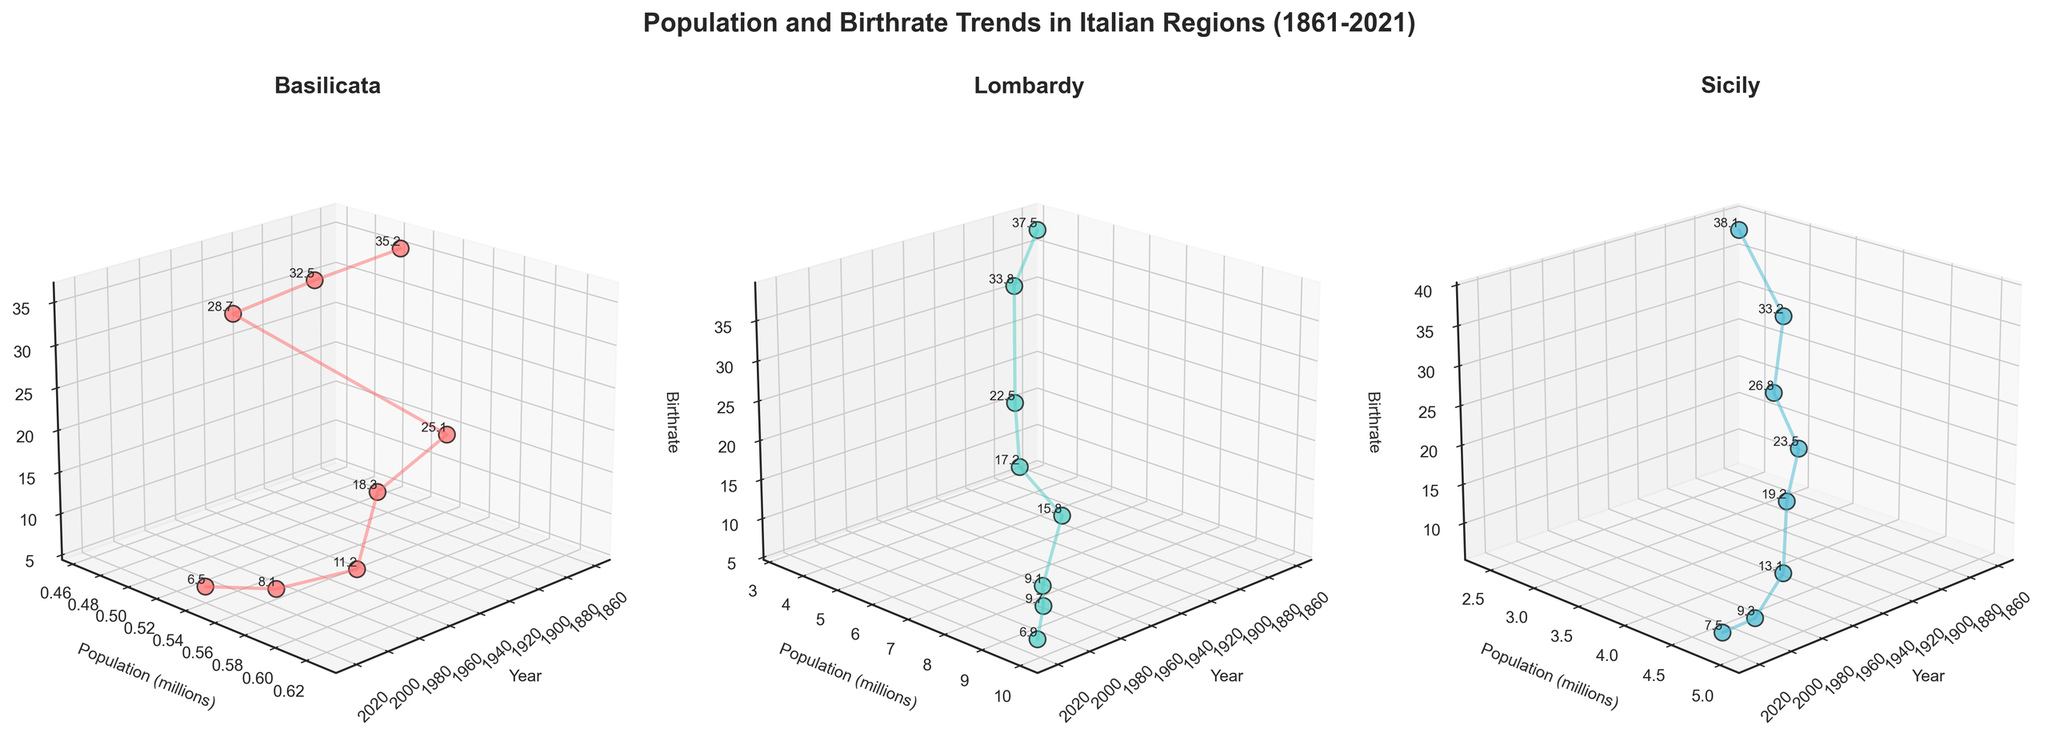Which region has the highest population in 2021? By looking at the scatter plots, we can find the data point for the year 2021. For Basilicata, the population is about 0.54 million, for Lombardy, it is about 9.97 million, and for Sicily, it is around 4.83 million. Lombardy has the highest population.
Answer: Lombardy How did the population of Basilicata change from 1861 to 1951? In the 3D scatter plot for Basilicata, locate the points for 1861 and 1951 on the x-axis for the year. The population in 1861 is about 0.509 million, and in 1951, it is around 0.627 million, indicating an increase of approximately 0.118 million.
Answer: Increased by 0.118 million What was the trend in birthrate for Basilicata from 1951 to 2021? Look at the trail created by the birthrate points for Basilicata from 1951 to 2021. The birthrate decreases from 25.1 to 6.5 over this period.
Answer: Decreasing trend In which year did Lombardy have roughly the same birthrate as Basilicata in 1931? Locate the birthrate for Basilicata in 1931, which is around 28.7. Then check the plot for Lombardy and see which year has a similar birthrate. Lombardy in 1861 has a birthrate around 30, which is close.
Answer: 1861 Compare the birthrate trends for Sicily and Basilicata between 1861 and 2021. Observe the birthrate lines in the 3D plots for both regions. Both regions show a significant decrease in birthrate from 1861 to 2021.
Answer: Both decreased significantly What is the difference between the birthrate and death rate in Basilicata in 2021? Find the birthrate for Basilicata in 2021, which is 6.5, and the death rate, which is 12.8. The difference is 12.8 - 6.5.
Answer: 6.3 Which region experienced a population decrease between 2011 and 2021? Compare the populations for each region between 2011 and 2021 on their respective plots. Both Basilicata and Sicily show population decreases in this period.
Answer: Basilicata and Sicily When did Basilicata have the highest recorded population, and what was it? Identify the highest point in the population line for Basilicata across all years. The highest recorded population was around 0.627 million in 1951.
Answer: 1951, 0.627 million 